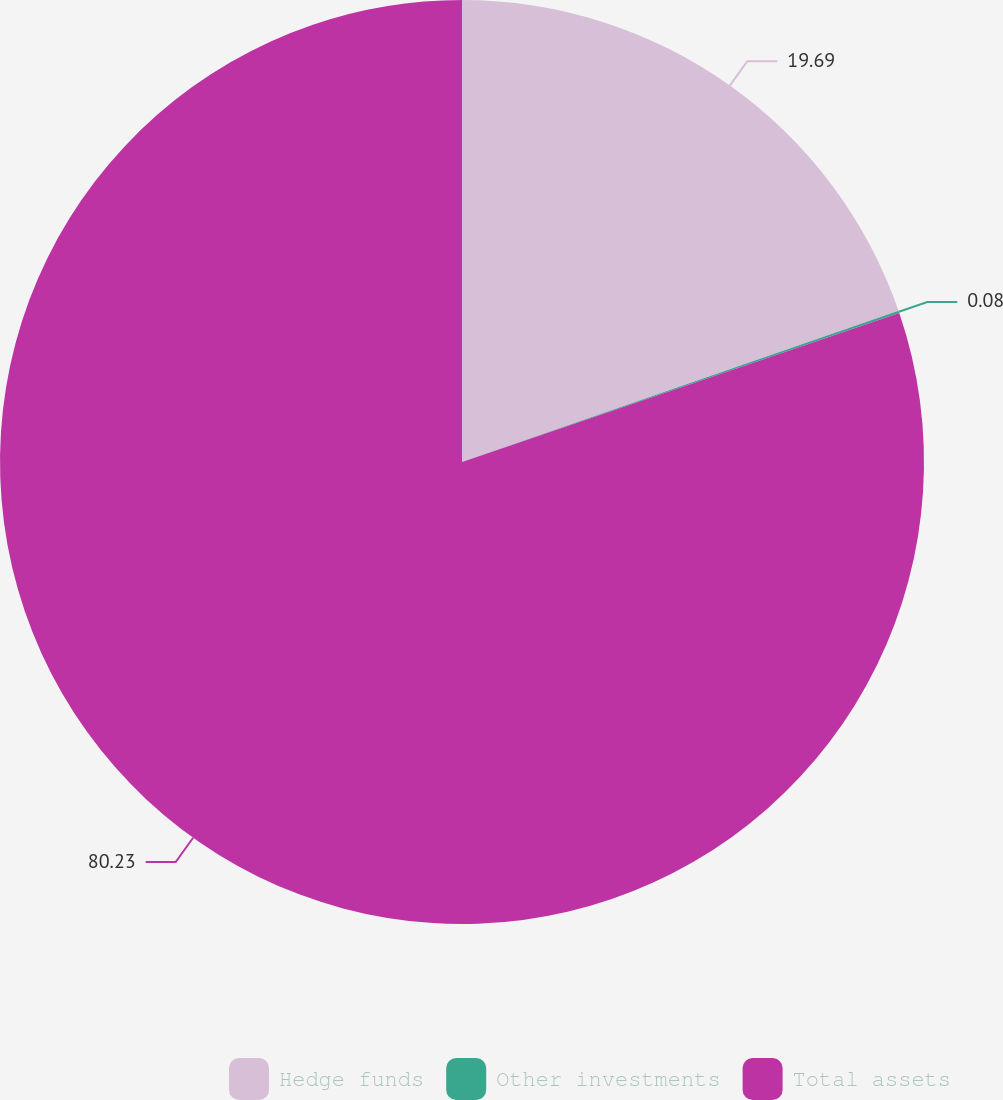Convert chart. <chart><loc_0><loc_0><loc_500><loc_500><pie_chart><fcel>Hedge funds<fcel>Other investments<fcel>Total assets<nl><fcel>19.69%<fcel>0.08%<fcel>80.23%<nl></chart> 